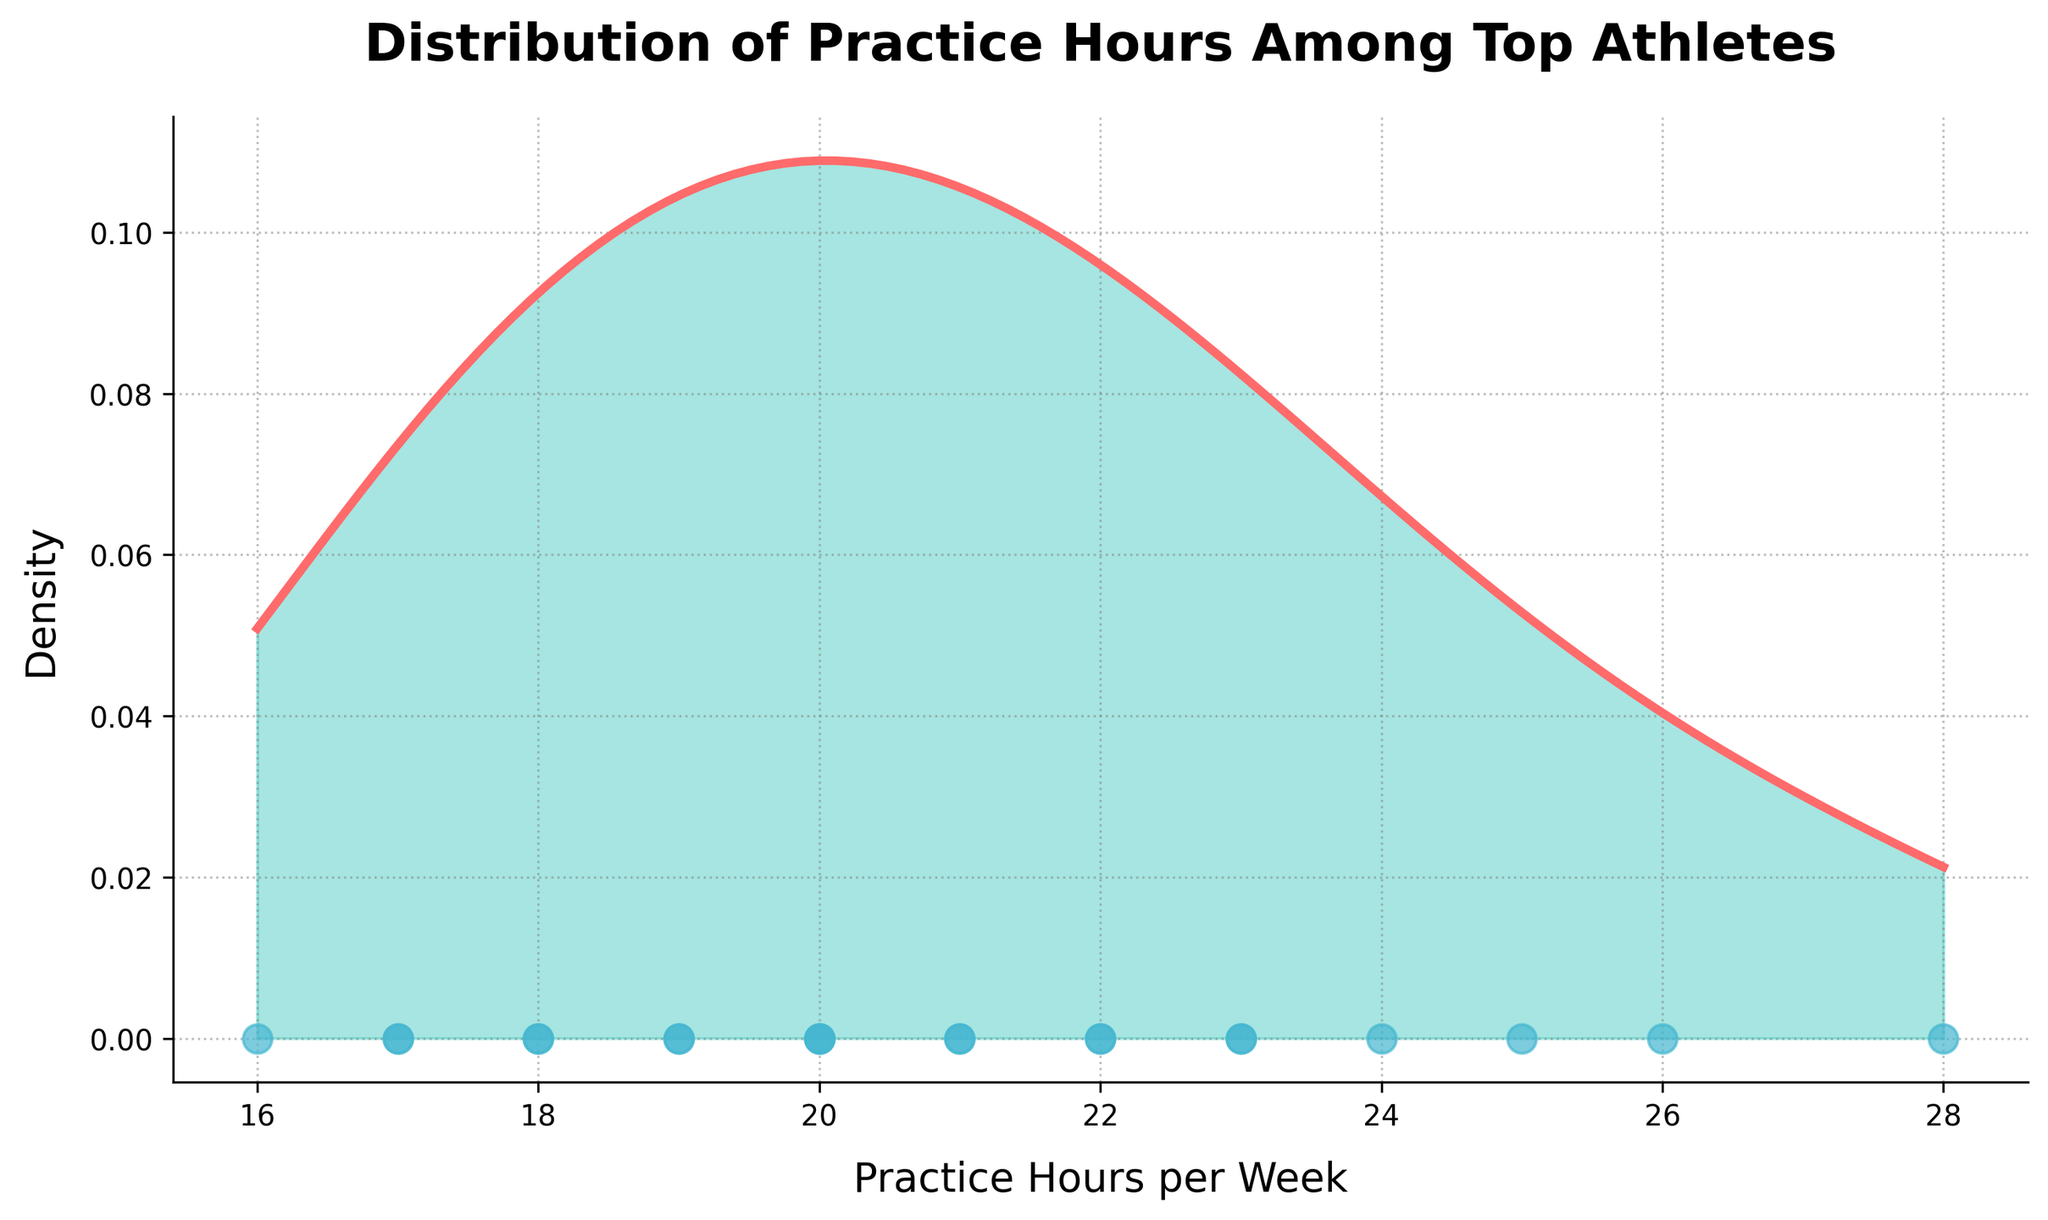What's the title of the plot? The title is written at the top of the plot. In this case, it reads "Distribution of Practice Hours Among Top Athletes."
Answer: Distribution of Practice Hours Among Top Athletes What is the range of practice hours per week shown in the plot? By observing the x-axis of the plot, you can see the minimum and maximum practice hours per week. The range goes from 16 to 28 hours.
Answer: 16 to 28 hours Which athlete practices the most hours per week? The scatter plot points can be referenced where each point represents an athlete. The highest point is at 28 hours, indicating Michael Phelps.
Answer: Michael Phelps What is the peak density of practice hours? The density curve peaks at a certain point. The highest density can be observed around 20 practice hours per week.
Answer: Around 20 hours How many athletes practice exactly 20 hours per week? By looking at the scatter plot at the x=20 mark, there are three points visible. Hence, three athletes practice 20 hours per week.
Answer: Three athletes Approximately how does the density at 18 hours compare to the density at 24 hours? One must observe the height of the density curve at both 18 and 24 hours. The density is higher at 18 hours than at 24 hours.
Answer: Higher at 18 hours What could be the median practice hours per week based on the density plot? The median can be observed where the area under the density curve is split into two equal parts. It seems to be around 21 hours per week.
Answer: Around 21 hours What is the interquartile range (IQR) of practice hours per week? To find the IQR, one must identify the first and third quartiles (Q1, Q3), which would represent the 25th and 75th percentiles of the area under the density curve. These appear roughly around 18 and 24 hours respectively: 24 - 18 = 6 hours.
Answer: 6 hours How does the distribution skew? Density plots can show skewness by observing the tail ends. The plot shows a longer tail to the right, indicating a positive skew.
Answer: Positively skewed Which athlete practices the least hours per week? The scatter plot points reveal the lowest practice hours per week at 16 hours, which corresponds to Shaquille O'Neal.
Answer: Shaquille O'Neal 